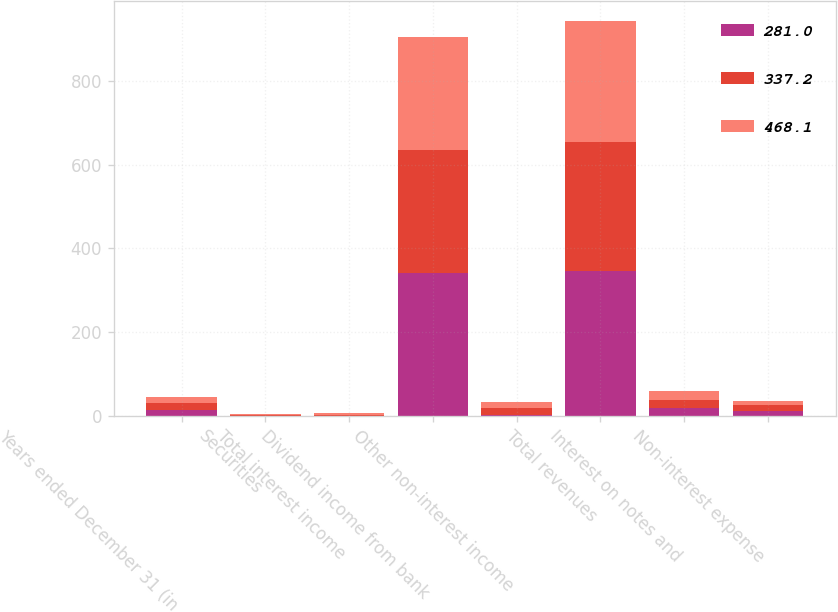Convert chart to OTSL. <chart><loc_0><loc_0><loc_500><loc_500><stacked_bar_chart><ecel><fcel>Years ended December 31 (in<fcel>Securities<fcel>Total interest income<fcel>Dividend income from bank<fcel>Other non-interest income<fcel>Total revenues<fcel>Interest on notes and<fcel>Non-interest expense<nl><fcel>281<fcel>14.8<fcel>0.4<fcel>0.4<fcel>342<fcel>2.3<fcel>344.7<fcel>18.7<fcel>11.4<nl><fcel>337.2<fcel>14.8<fcel>1.1<fcel>1.1<fcel>292<fcel>16.9<fcel>308.8<fcel>19<fcel>13.9<nl><fcel>468.1<fcel>14.8<fcel>3.4<fcel>4.4<fcel>271<fcel>14.8<fcel>290.2<fcel>22.5<fcel>9.6<nl></chart> 